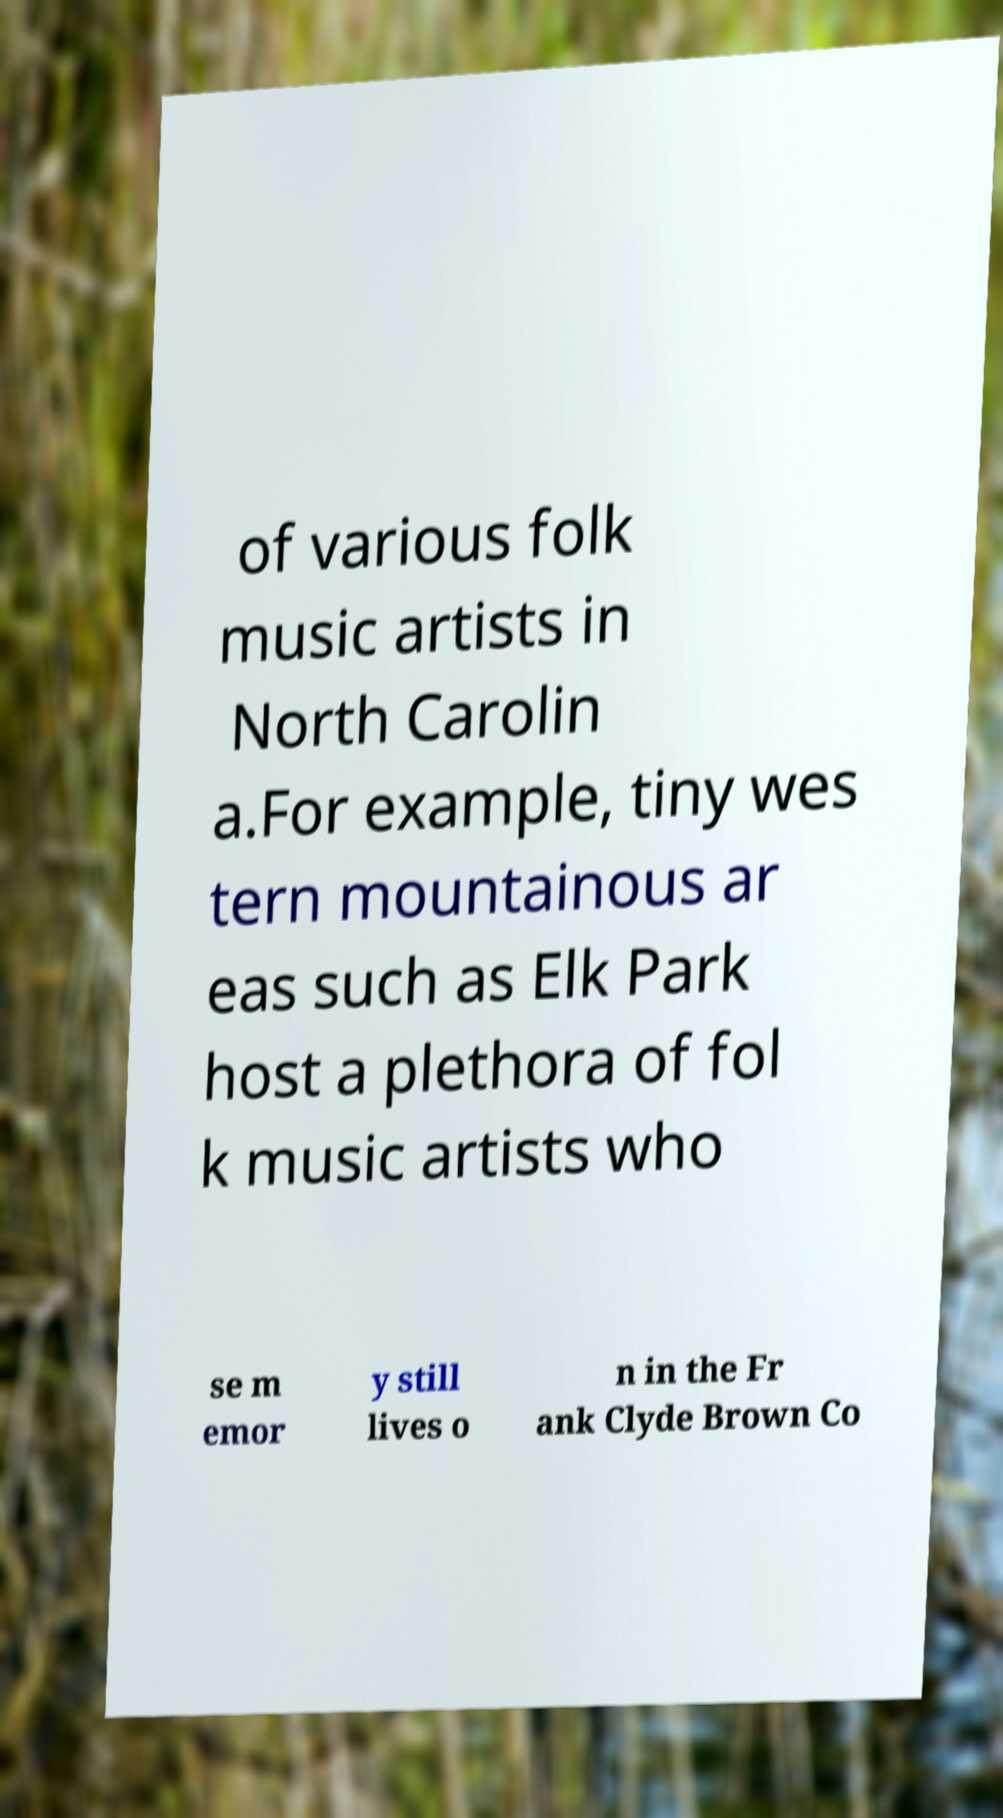Please identify and transcribe the text found in this image. of various folk music artists in North Carolin a.For example, tiny wes tern mountainous ar eas such as Elk Park host a plethora of fol k music artists who se m emor y still lives o n in the Fr ank Clyde Brown Co 